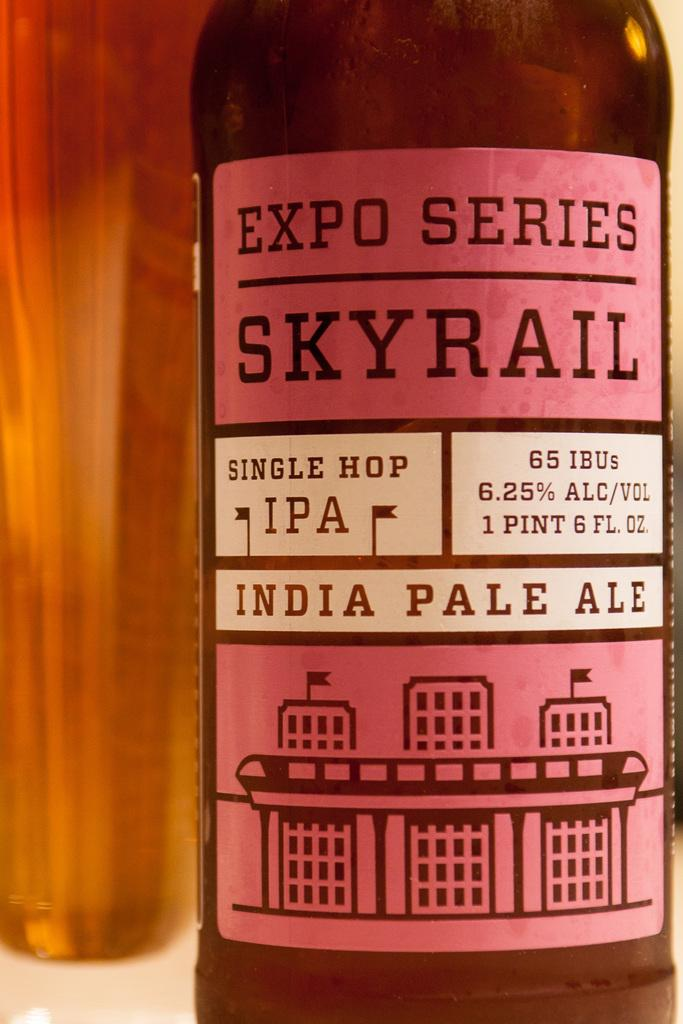<image>
Summarize the visual content of the image. A bottle of Indian pale ale has a pink label which shows the alcohol content as 6.25%. 